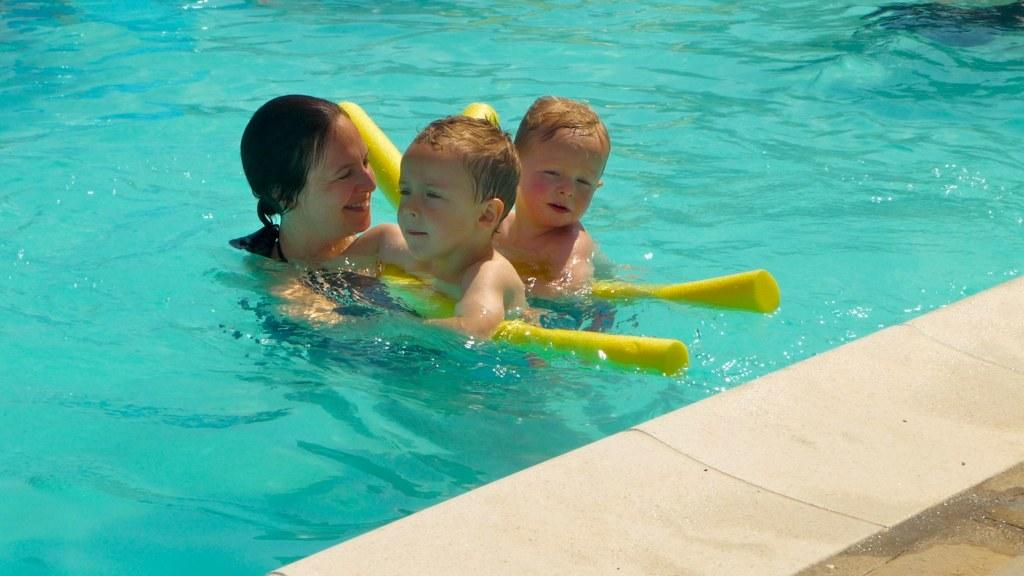How many people are in the water in the image? There are three people in the water in the image. What are the people holding in the image? The people are holding objects in the image. Can you describe the pathway visible in the image? There is a pathway at the bottom right side of the image. What type of polish is being applied to the transport in the image? There is no transport or polish present in the image; it features three people in the water holding objects. 